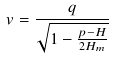Convert formula to latex. <formula><loc_0><loc_0><loc_500><loc_500>v = \frac { q } { \sqrt { 1 - \frac { p - H } { 2 H _ { m } } } }</formula> 